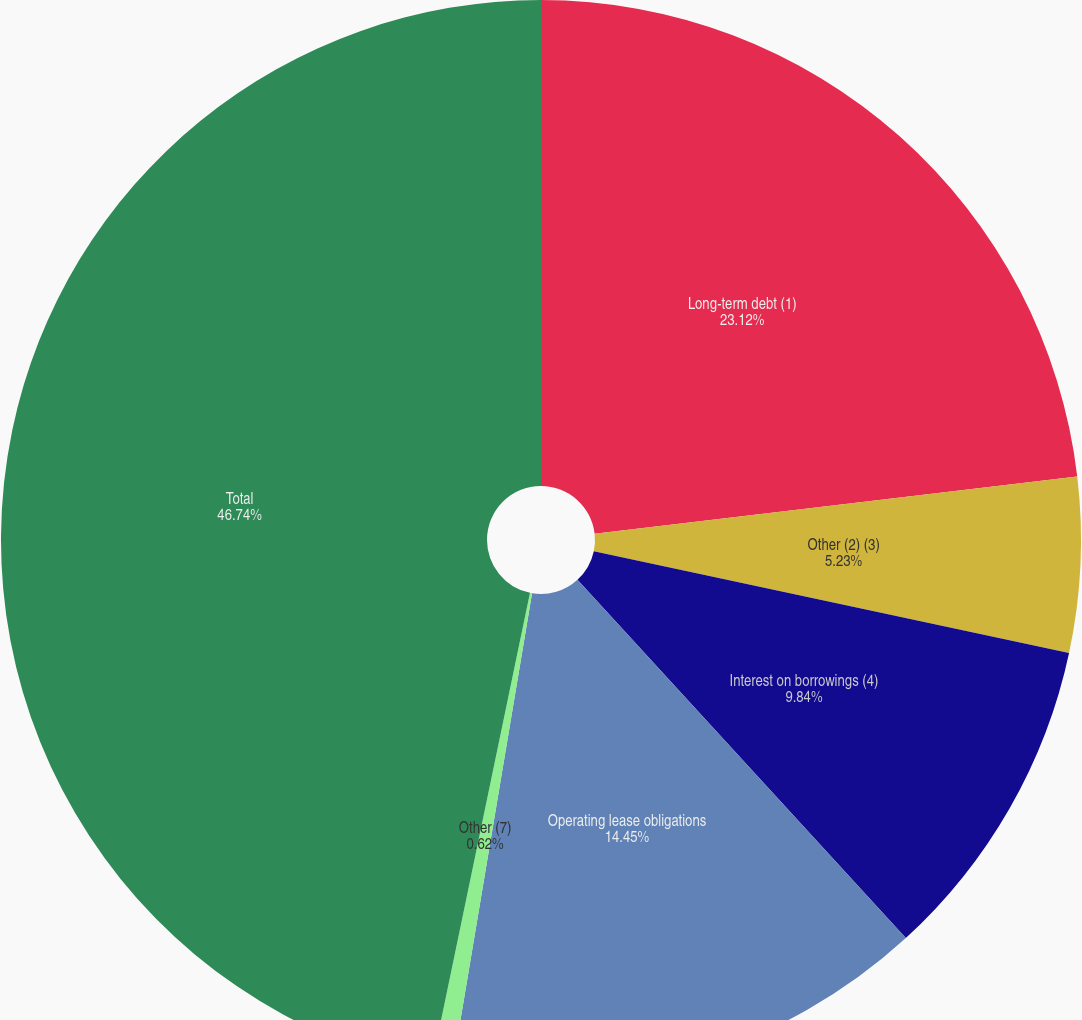Convert chart to OTSL. <chart><loc_0><loc_0><loc_500><loc_500><pie_chart><fcel>Long-term debt (1)<fcel>Other (2) (3)<fcel>Interest on borrowings (4)<fcel>Operating lease obligations<fcel>Other (7)<fcel>Total<nl><fcel>23.12%<fcel>5.23%<fcel>9.84%<fcel>14.45%<fcel>0.62%<fcel>46.73%<nl></chart> 